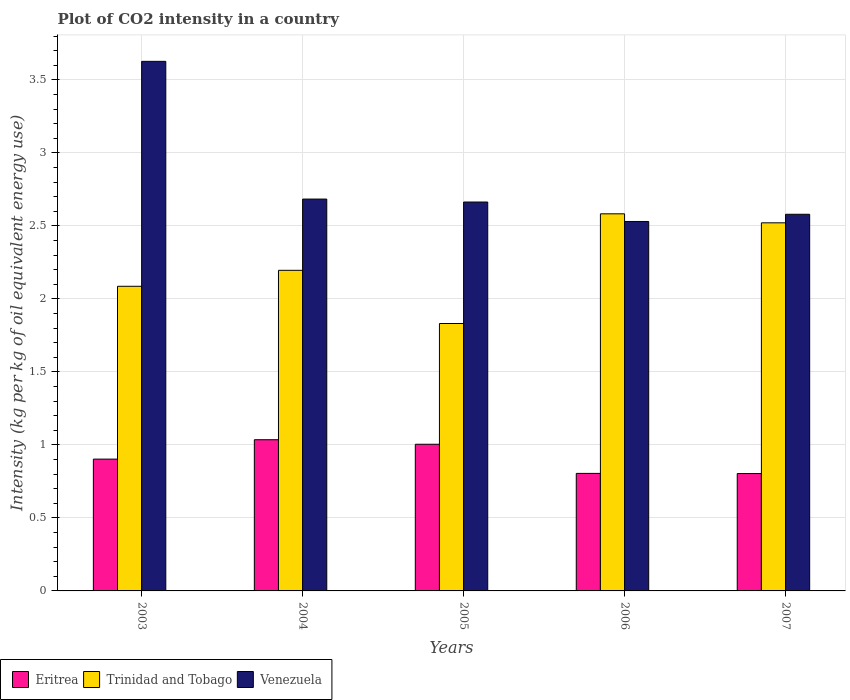How many different coloured bars are there?
Offer a very short reply. 3. How many groups of bars are there?
Provide a short and direct response. 5. Are the number of bars per tick equal to the number of legend labels?
Provide a short and direct response. Yes. How many bars are there on the 3rd tick from the left?
Give a very brief answer. 3. In how many cases, is the number of bars for a given year not equal to the number of legend labels?
Make the answer very short. 0. What is the CO2 intensity in in Trinidad and Tobago in 2007?
Ensure brevity in your answer.  2.52. Across all years, what is the maximum CO2 intensity in in Venezuela?
Your answer should be compact. 3.63. Across all years, what is the minimum CO2 intensity in in Eritrea?
Make the answer very short. 0.8. In which year was the CO2 intensity in in Venezuela maximum?
Your answer should be very brief. 2003. In which year was the CO2 intensity in in Venezuela minimum?
Provide a succinct answer. 2006. What is the total CO2 intensity in in Eritrea in the graph?
Your response must be concise. 4.55. What is the difference between the CO2 intensity in in Eritrea in 2003 and that in 2005?
Keep it short and to the point. -0.1. What is the difference between the CO2 intensity in in Venezuela in 2005 and the CO2 intensity in in Trinidad and Tobago in 2004?
Your response must be concise. 0.47. What is the average CO2 intensity in in Eritrea per year?
Give a very brief answer. 0.91. In the year 2004, what is the difference between the CO2 intensity in in Venezuela and CO2 intensity in in Eritrea?
Give a very brief answer. 1.65. In how many years, is the CO2 intensity in in Venezuela greater than 3.5 kg?
Provide a succinct answer. 1. What is the ratio of the CO2 intensity in in Venezuela in 2006 to that in 2007?
Offer a very short reply. 0.98. Is the CO2 intensity in in Trinidad and Tobago in 2005 less than that in 2007?
Keep it short and to the point. Yes. What is the difference between the highest and the second highest CO2 intensity in in Venezuela?
Offer a very short reply. 0.94. What is the difference between the highest and the lowest CO2 intensity in in Venezuela?
Give a very brief answer. 1.1. Is the sum of the CO2 intensity in in Venezuela in 2005 and 2007 greater than the maximum CO2 intensity in in Eritrea across all years?
Provide a short and direct response. Yes. What does the 2nd bar from the left in 2005 represents?
Provide a short and direct response. Trinidad and Tobago. What does the 2nd bar from the right in 2006 represents?
Make the answer very short. Trinidad and Tobago. Is it the case that in every year, the sum of the CO2 intensity in in Eritrea and CO2 intensity in in Trinidad and Tobago is greater than the CO2 intensity in in Venezuela?
Ensure brevity in your answer.  No. Are all the bars in the graph horizontal?
Keep it short and to the point. No. Are the values on the major ticks of Y-axis written in scientific E-notation?
Offer a very short reply. No. Does the graph contain any zero values?
Keep it short and to the point. No. What is the title of the graph?
Your answer should be very brief. Plot of CO2 intensity in a country. What is the label or title of the X-axis?
Your response must be concise. Years. What is the label or title of the Y-axis?
Make the answer very short. Intensity (kg per kg of oil equivalent energy use). What is the Intensity (kg per kg of oil equivalent energy use) of Eritrea in 2003?
Ensure brevity in your answer.  0.9. What is the Intensity (kg per kg of oil equivalent energy use) of Trinidad and Tobago in 2003?
Provide a succinct answer. 2.09. What is the Intensity (kg per kg of oil equivalent energy use) in Venezuela in 2003?
Provide a succinct answer. 3.63. What is the Intensity (kg per kg of oil equivalent energy use) of Eritrea in 2004?
Keep it short and to the point. 1.04. What is the Intensity (kg per kg of oil equivalent energy use) of Trinidad and Tobago in 2004?
Ensure brevity in your answer.  2.2. What is the Intensity (kg per kg of oil equivalent energy use) in Venezuela in 2004?
Provide a short and direct response. 2.68. What is the Intensity (kg per kg of oil equivalent energy use) of Eritrea in 2005?
Give a very brief answer. 1. What is the Intensity (kg per kg of oil equivalent energy use) of Trinidad and Tobago in 2005?
Give a very brief answer. 1.83. What is the Intensity (kg per kg of oil equivalent energy use) in Venezuela in 2005?
Provide a succinct answer. 2.66. What is the Intensity (kg per kg of oil equivalent energy use) in Eritrea in 2006?
Your response must be concise. 0.81. What is the Intensity (kg per kg of oil equivalent energy use) in Trinidad and Tobago in 2006?
Offer a very short reply. 2.58. What is the Intensity (kg per kg of oil equivalent energy use) of Venezuela in 2006?
Offer a very short reply. 2.53. What is the Intensity (kg per kg of oil equivalent energy use) of Eritrea in 2007?
Your answer should be compact. 0.8. What is the Intensity (kg per kg of oil equivalent energy use) in Trinidad and Tobago in 2007?
Offer a very short reply. 2.52. What is the Intensity (kg per kg of oil equivalent energy use) in Venezuela in 2007?
Offer a very short reply. 2.58. Across all years, what is the maximum Intensity (kg per kg of oil equivalent energy use) in Eritrea?
Your response must be concise. 1.04. Across all years, what is the maximum Intensity (kg per kg of oil equivalent energy use) of Trinidad and Tobago?
Provide a succinct answer. 2.58. Across all years, what is the maximum Intensity (kg per kg of oil equivalent energy use) of Venezuela?
Give a very brief answer. 3.63. Across all years, what is the minimum Intensity (kg per kg of oil equivalent energy use) in Eritrea?
Your response must be concise. 0.8. Across all years, what is the minimum Intensity (kg per kg of oil equivalent energy use) of Trinidad and Tobago?
Your answer should be very brief. 1.83. Across all years, what is the minimum Intensity (kg per kg of oil equivalent energy use) in Venezuela?
Offer a terse response. 2.53. What is the total Intensity (kg per kg of oil equivalent energy use) of Eritrea in the graph?
Your answer should be compact. 4.55. What is the total Intensity (kg per kg of oil equivalent energy use) of Trinidad and Tobago in the graph?
Provide a succinct answer. 11.22. What is the total Intensity (kg per kg of oil equivalent energy use) in Venezuela in the graph?
Your answer should be compact. 14.09. What is the difference between the Intensity (kg per kg of oil equivalent energy use) of Eritrea in 2003 and that in 2004?
Your response must be concise. -0.13. What is the difference between the Intensity (kg per kg of oil equivalent energy use) of Trinidad and Tobago in 2003 and that in 2004?
Keep it short and to the point. -0.11. What is the difference between the Intensity (kg per kg of oil equivalent energy use) in Venezuela in 2003 and that in 2004?
Offer a terse response. 0.94. What is the difference between the Intensity (kg per kg of oil equivalent energy use) in Eritrea in 2003 and that in 2005?
Your response must be concise. -0.1. What is the difference between the Intensity (kg per kg of oil equivalent energy use) of Trinidad and Tobago in 2003 and that in 2005?
Offer a terse response. 0.25. What is the difference between the Intensity (kg per kg of oil equivalent energy use) in Venezuela in 2003 and that in 2005?
Provide a succinct answer. 0.96. What is the difference between the Intensity (kg per kg of oil equivalent energy use) in Eritrea in 2003 and that in 2006?
Offer a terse response. 0.1. What is the difference between the Intensity (kg per kg of oil equivalent energy use) in Trinidad and Tobago in 2003 and that in 2006?
Your answer should be compact. -0.5. What is the difference between the Intensity (kg per kg of oil equivalent energy use) in Venezuela in 2003 and that in 2006?
Offer a terse response. 1.1. What is the difference between the Intensity (kg per kg of oil equivalent energy use) of Eritrea in 2003 and that in 2007?
Your answer should be compact. 0.1. What is the difference between the Intensity (kg per kg of oil equivalent energy use) of Trinidad and Tobago in 2003 and that in 2007?
Offer a very short reply. -0.43. What is the difference between the Intensity (kg per kg of oil equivalent energy use) of Venezuela in 2003 and that in 2007?
Keep it short and to the point. 1.05. What is the difference between the Intensity (kg per kg of oil equivalent energy use) in Eritrea in 2004 and that in 2005?
Provide a short and direct response. 0.03. What is the difference between the Intensity (kg per kg of oil equivalent energy use) in Trinidad and Tobago in 2004 and that in 2005?
Ensure brevity in your answer.  0.36. What is the difference between the Intensity (kg per kg of oil equivalent energy use) of Venezuela in 2004 and that in 2005?
Give a very brief answer. 0.02. What is the difference between the Intensity (kg per kg of oil equivalent energy use) in Eritrea in 2004 and that in 2006?
Provide a succinct answer. 0.23. What is the difference between the Intensity (kg per kg of oil equivalent energy use) of Trinidad and Tobago in 2004 and that in 2006?
Offer a terse response. -0.39. What is the difference between the Intensity (kg per kg of oil equivalent energy use) in Venezuela in 2004 and that in 2006?
Your response must be concise. 0.15. What is the difference between the Intensity (kg per kg of oil equivalent energy use) of Eritrea in 2004 and that in 2007?
Give a very brief answer. 0.23. What is the difference between the Intensity (kg per kg of oil equivalent energy use) of Trinidad and Tobago in 2004 and that in 2007?
Your answer should be compact. -0.33. What is the difference between the Intensity (kg per kg of oil equivalent energy use) in Venezuela in 2004 and that in 2007?
Ensure brevity in your answer.  0.1. What is the difference between the Intensity (kg per kg of oil equivalent energy use) in Eritrea in 2005 and that in 2006?
Your answer should be compact. 0.2. What is the difference between the Intensity (kg per kg of oil equivalent energy use) in Trinidad and Tobago in 2005 and that in 2006?
Provide a short and direct response. -0.75. What is the difference between the Intensity (kg per kg of oil equivalent energy use) in Venezuela in 2005 and that in 2006?
Your response must be concise. 0.13. What is the difference between the Intensity (kg per kg of oil equivalent energy use) in Eritrea in 2005 and that in 2007?
Offer a very short reply. 0.2. What is the difference between the Intensity (kg per kg of oil equivalent energy use) in Trinidad and Tobago in 2005 and that in 2007?
Keep it short and to the point. -0.69. What is the difference between the Intensity (kg per kg of oil equivalent energy use) in Venezuela in 2005 and that in 2007?
Offer a terse response. 0.08. What is the difference between the Intensity (kg per kg of oil equivalent energy use) of Trinidad and Tobago in 2006 and that in 2007?
Provide a succinct answer. 0.06. What is the difference between the Intensity (kg per kg of oil equivalent energy use) of Venezuela in 2006 and that in 2007?
Ensure brevity in your answer.  -0.05. What is the difference between the Intensity (kg per kg of oil equivalent energy use) in Eritrea in 2003 and the Intensity (kg per kg of oil equivalent energy use) in Trinidad and Tobago in 2004?
Offer a terse response. -1.29. What is the difference between the Intensity (kg per kg of oil equivalent energy use) of Eritrea in 2003 and the Intensity (kg per kg of oil equivalent energy use) of Venezuela in 2004?
Provide a succinct answer. -1.78. What is the difference between the Intensity (kg per kg of oil equivalent energy use) of Trinidad and Tobago in 2003 and the Intensity (kg per kg of oil equivalent energy use) of Venezuela in 2004?
Your response must be concise. -0.6. What is the difference between the Intensity (kg per kg of oil equivalent energy use) of Eritrea in 2003 and the Intensity (kg per kg of oil equivalent energy use) of Trinidad and Tobago in 2005?
Keep it short and to the point. -0.93. What is the difference between the Intensity (kg per kg of oil equivalent energy use) of Eritrea in 2003 and the Intensity (kg per kg of oil equivalent energy use) of Venezuela in 2005?
Provide a succinct answer. -1.76. What is the difference between the Intensity (kg per kg of oil equivalent energy use) of Trinidad and Tobago in 2003 and the Intensity (kg per kg of oil equivalent energy use) of Venezuela in 2005?
Ensure brevity in your answer.  -0.58. What is the difference between the Intensity (kg per kg of oil equivalent energy use) in Eritrea in 2003 and the Intensity (kg per kg of oil equivalent energy use) in Trinidad and Tobago in 2006?
Make the answer very short. -1.68. What is the difference between the Intensity (kg per kg of oil equivalent energy use) of Eritrea in 2003 and the Intensity (kg per kg of oil equivalent energy use) of Venezuela in 2006?
Keep it short and to the point. -1.63. What is the difference between the Intensity (kg per kg of oil equivalent energy use) of Trinidad and Tobago in 2003 and the Intensity (kg per kg of oil equivalent energy use) of Venezuela in 2006?
Your answer should be compact. -0.44. What is the difference between the Intensity (kg per kg of oil equivalent energy use) of Eritrea in 2003 and the Intensity (kg per kg of oil equivalent energy use) of Trinidad and Tobago in 2007?
Keep it short and to the point. -1.62. What is the difference between the Intensity (kg per kg of oil equivalent energy use) in Eritrea in 2003 and the Intensity (kg per kg of oil equivalent energy use) in Venezuela in 2007?
Your response must be concise. -1.68. What is the difference between the Intensity (kg per kg of oil equivalent energy use) of Trinidad and Tobago in 2003 and the Intensity (kg per kg of oil equivalent energy use) of Venezuela in 2007?
Provide a short and direct response. -0.49. What is the difference between the Intensity (kg per kg of oil equivalent energy use) of Eritrea in 2004 and the Intensity (kg per kg of oil equivalent energy use) of Trinidad and Tobago in 2005?
Offer a very short reply. -0.8. What is the difference between the Intensity (kg per kg of oil equivalent energy use) in Eritrea in 2004 and the Intensity (kg per kg of oil equivalent energy use) in Venezuela in 2005?
Provide a short and direct response. -1.63. What is the difference between the Intensity (kg per kg of oil equivalent energy use) of Trinidad and Tobago in 2004 and the Intensity (kg per kg of oil equivalent energy use) of Venezuela in 2005?
Provide a succinct answer. -0.47. What is the difference between the Intensity (kg per kg of oil equivalent energy use) in Eritrea in 2004 and the Intensity (kg per kg of oil equivalent energy use) in Trinidad and Tobago in 2006?
Provide a short and direct response. -1.55. What is the difference between the Intensity (kg per kg of oil equivalent energy use) in Eritrea in 2004 and the Intensity (kg per kg of oil equivalent energy use) in Venezuela in 2006?
Ensure brevity in your answer.  -1.49. What is the difference between the Intensity (kg per kg of oil equivalent energy use) of Trinidad and Tobago in 2004 and the Intensity (kg per kg of oil equivalent energy use) of Venezuela in 2006?
Offer a very short reply. -0.33. What is the difference between the Intensity (kg per kg of oil equivalent energy use) of Eritrea in 2004 and the Intensity (kg per kg of oil equivalent energy use) of Trinidad and Tobago in 2007?
Your answer should be very brief. -1.49. What is the difference between the Intensity (kg per kg of oil equivalent energy use) in Eritrea in 2004 and the Intensity (kg per kg of oil equivalent energy use) in Venezuela in 2007?
Your answer should be compact. -1.54. What is the difference between the Intensity (kg per kg of oil equivalent energy use) of Trinidad and Tobago in 2004 and the Intensity (kg per kg of oil equivalent energy use) of Venezuela in 2007?
Keep it short and to the point. -0.38. What is the difference between the Intensity (kg per kg of oil equivalent energy use) of Eritrea in 2005 and the Intensity (kg per kg of oil equivalent energy use) of Trinidad and Tobago in 2006?
Make the answer very short. -1.58. What is the difference between the Intensity (kg per kg of oil equivalent energy use) in Eritrea in 2005 and the Intensity (kg per kg of oil equivalent energy use) in Venezuela in 2006?
Offer a terse response. -1.53. What is the difference between the Intensity (kg per kg of oil equivalent energy use) in Trinidad and Tobago in 2005 and the Intensity (kg per kg of oil equivalent energy use) in Venezuela in 2006?
Offer a terse response. -0.7. What is the difference between the Intensity (kg per kg of oil equivalent energy use) in Eritrea in 2005 and the Intensity (kg per kg of oil equivalent energy use) in Trinidad and Tobago in 2007?
Give a very brief answer. -1.52. What is the difference between the Intensity (kg per kg of oil equivalent energy use) in Eritrea in 2005 and the Intensity (kg per kg of oil equivalent energy use) in Venezuela in 2007?
Your response must be concise. -1.58. What is the difference between the Intensity (kg per kg of oil equivalent energy use) of Trinidad and Tobago in 2005 and the Intensity (kg per kg of oil equivalent energy use) of Venezuela in 2007?
Provide a succinct answer. -0.75. What is the difference between the Intensity (kg per kg of oil equivalent energy use) of Eritrea in 2006 and the Intensity (kg per kg of oil equivalent energy use) of Trinidad and Tobago in 2007?
Keep it short and to the point. -1.72. What is the difference between the Intensity (kg per kg of oil equivalent energy use) in Eritrea in 2006 and the Intensity (kg per kg of oil equivalent energy use) in Venezuela in 2007?
Offer a very short reply. -1.77. What is the difference between the Intensity (kg per kg of oil equivalent energy use) in Trinidad and Tobago in 2006 and the Intensity (kg per kg of oil equivalent energy use) in Venezuela in 2007?
Offer a terse response. 0. What is the average Intensity (kg per kg of oil equivalent energy use) in Eritrea per year?
Your response must be concise. 0.91. What is the average Intensity (kg per kg of oil equivalent energy use) of Trinidad and Tobago per year?
Give a very brief answer. 2.24. What is the average Intensity (kg per kg of oil equivalent energy use) in Venezuela per year?
Offer a very short reply. 2.82. In the year 2003, what is the difference between the Intensity (kg per kg of oil equivalent energy use) of Eritrea and Intensity (kg per kg of oil equivalent energy use) of Trinidad and Tobago?
Make the answer very short. -1.18. In the year 2003, what is the difference between the Intensity (kg per kg of oil equivalent energy use) of Eritrea and Intensity (kg per kg of oil equivalent energy use) of Venezuela?
Your answer should be very brief. -2.72. In the year 2003, what is the difference between the Intensity (kg per kg of oil equivalent energy use) of Trinidad and Tobago and Intensity (kg per kg of oil equivalent energy use) of Venezuela?
Make the answer very short. -1.54. In the year 2004, what is the difference between the Intensity (kg per kg of oil equivalent energy use) of Eritrea and Intensity (kg per kg of oil equivalent energy use) of Trinidad and Tobago?
Offer a terse response. -1.16. In the year 2004, what is the difference between the Intensity (kg per kg of oil equivalent energy use) in Eritrea and Intensity (kg per kg of oil equivalent energy use) in Venezuela?
Offer a very short reply. -1.65. In the year 2004, what is the difference between the Intensity (kg per kg of oil equivalent energy use) of Trinidad and Tobago and Intensity (kg per kg of oil equivalent energy use) of Venezuela?
Offer a very short reply. -0.49. In the year 2005, what is the difference between the Intensity (kg per kg of oil equivalent energy use) of Eritrea and Intensity (kg per kg of oil equivalent energy use) of Trinidad and Tobago?
Keep it short and to the point. -0.83. In the year 2005, what is the difference between the Intensity (kg per kg of oil equivalent energy use) of Eritrea and Intensity (kg per kg of oil equivalent energy use) of Venezuela?
Provide a succinct answer. -1.66. In the year 2005, what is the difference between the Intensity (kg per kg of oil equivalent energy use) in Trinidad and Tobago and Intensity (kg per kg of oil equivalent energy use) in Venezuela?
Make the answer very short. -0.83. In the year 2006, what is the difference between the Intensity (kg per kg of oil equivalent energy use) of Eritrea and Intensity (kg per kg of oil equivalent energy use) of Trinidad and Tobago?
Ensure brevity in your answer.  -1.78. In the year 2006, what is the difference between the Intensity (kg per kg of oil equivalent energy use) in Eritrea and Intensity (kg per kg of oil equivalent energy use) in Venezuela?
Provide a short and direct response. -1.73. In the year 2006, what is the difference between the Intensity (kg per kg of oil equivalent energy use) in Trinidad and Tobago and Intensity (kg per kg of oil equivalent energy use) in Venezuela?
Your answer should be compact. 0.05. In the year 2007, what is the difference between the Intensity (kg per kg of oil equivalent energy use) of Eritrea and Intensity (kg per kg of oil equivalent energy use) of Trinidad and Tobago?
Provide a short and direct response. -1.72. In the year 2007, what is the difference between the Intensity (kg per kg of oil equivalent energy use) of Eritrea and Intensity (kg per kg of oil equivalent energy use) of Venezuela?
Ensure brevity in your answer.  -1.78. In the year 2007, what is the difference between the Intensity (kg per kg of oil equivalent energy use) in Trinidad and Tobago and Intensity (kg per kg of oil equivalent energy use) in Venezuela?
Offer a very short reply. -0.06. What is the ratio of the Intensity (kg per kg of oil equivalent energy use) of Eritrea in 2003 to that in 2004?
Your answer should be very brief. 0.87. What is the ratio of the Intensity (kg per kg of oil equivalent energy use) of Trinidad and Tobago in 2003 to that in 2004?
Provide a succinct answer. 0.95. What is the ratio of the Intensity (kg per kg of oil equivalent energy use) of Venezuela in 2003 to that in 2004?
Provide a succinct answer. 1.35. What is the ratio of the Intensity (kg per kg of oil equivalent energy use) of Eritrea in 2003 to that in 2005?
Your answer should be very brief. 0.9. What is the ratio of the Intensity (kg per kg of oil equivalent energy use) of Trinidad and Tobago in 2003 to that in 2005?
Your answer should be very brief. 1.14. What is the ratio of the Intensity (kg per kg of oil equivalent energy use) of Venezuela in 2003 to that in 2005?
Offer a terse response. 1.36. What is the ratio of the Intensity (kg per kg of oil equivalent energy use) in Eritrea in 2003 to that in 2006?
Provide a succinct answer. 1.12. What is the ratio of the Intensity (kg per kg of oil equivalent energy use) in Trinidad and Tobago in 2003 to that in 2006?
Provide a succinct answer. 0.81. What is the ratio of the Intensity (kg per kg of oil equivalent energy use) of Venezuela in 2003 to that in 2006?
Your answer should be compact. 1.43. What is the ratio of the Intensity (kg per kg of oil equivalent energy use) of Eritrea in 2003 to that in 2007?
Your response must be concise. 1.12. What is the ratio of the Intensity (kg per kg of oil equivalent energy use) in Trinidad and Tobago in 2003 to that in 2007?
Provide a short and direct response. 0.83. What is the ratio of the Intensity (kg per kg of oil equivalent energy use) of Venezuela in 2003 to that in 2007?
Make the answer very short. 1.41. What is the ratio of the Intensity (kg per kg of oil equivalent energy use) of Eritrea in 2004 to that in 2005?
Ensure brevity in your answer.  1.03. What is the ratio of the Intensity (kg per kg of oil equivalent energy use) in Trinidad and Tobago in 2004 to that in 2005?
Your answer should be compact. 1.2. What is the ratio of the Intensity (kg per kg of oil equivalent energy use) in Venezuela in 2004 to that in 2005?
Provide a short and direct response. 1.01. What is the ratio of the Intensity (kg per kg of oil equivalent energy use) in Eritrea in 2004 to that in 2006?
Ensure brevity in your answer.  1.29. What is the ratio of the Intensity (kg per kg of oil equivalent energy use) of Trinidad and Tobago in 2004 to that in 2006?
Provide a short and direct response. 0.85. What is the ratio of the Intensity (kg per kg of oil equivalent energy use) of Venezuela in 2004 to that in 2006?
Provide a short and direct response. 1.06. What is the ratio of the Intensity (kg per kg of oil equivalent energy use) of Eritrea in 2004 to that in 2007?
Ensure brevity in your answer.  1.29. What is the ratio of the Intensity (kg per kg of oil equivalent energy use) in Trinidad and Tobago in 2004 to that in 2007?
Offer a very short reply. 0.87. What is the ratio of the Intensity (kg per kg of oil equivalent energy use) of Venezuela in 2004 to that in 2007?
Make the answer very short. 1.04. What is the ratio of the Intensity (kg per kg of oil equivalent energy use) of Eritrea in 2005 to that in 2006?
Make the answer very short. 1.25. What is the ratio of the Intensity (kg per kg of oil equivalent energy use) in Trinidad and Tobago in 2005 to that in 2006?
Provide a short and direct response. 0.71. What is the ratio of the Intensity (kg per kg of oil equivalent energy use) in Venezuela in 2005 to that in 2006?
Provide a succinct answer. 1.05. What is the ratio of the Intensity (kg per kg of oil equivalent energy use) in Eritrea in 2005 to that in 2007?
Ensure brevity in your answer.  1.25. What is the ratio of the Intensity (kg per kg of oil equivalent energy use) of Trinidad and Tobago in 2005 to that in 2007?
Keep it short and to the point. 0.73. What is the ratio of the Intensity (kg per kg of oil equivalent energy use) of Venezuela in 2005 to that in 2007?
Your response must be concise. 1.03. What is the ratio of the Intensity (kg per kg of oil equivalent energy use) in Trinidad and Tobago in 2006 to that in 2007?
Your response must be concise. 1.02. What is the ratio of the Intensity (kg per kg of oil equivalent energy use) of Venezuela in 2006 to that in 2007?
Ensure brevity in your answer.  0.98. What is the difference between the highest and the second highest Intensity (kg per kg of oil equivalent energy use) of Eritrea?
Provide a succinct answer. 0.03. What is the difference between the highest and the second highest Intensity (kg per kg of oil equivalent energy use) in Trinidad and Tobago?
Provide a short and direct response. 0.06. What is the difference between the highest and the second highest Intensity (kg per kg of oil equivalent energy use) of Venezuela?
Ensure brevity in your answer.  0.94. What is the difference between the highest and the lowest Intensity (kg per kg of oil equivalent energy use) of Eritrea?
Your answer should be compact. 0.23. What is the difference between the highest and the lowest Intensity (kg per kg of oil equivalent energy use) of Trinidad and Tobago?
Provide a succinct answer. 0.75. What is the difference between the highest and the lowest Intensity (kg per kg of oil equivalent energy use) of Venezuela?
Provide a succinct answer. 1.1. 